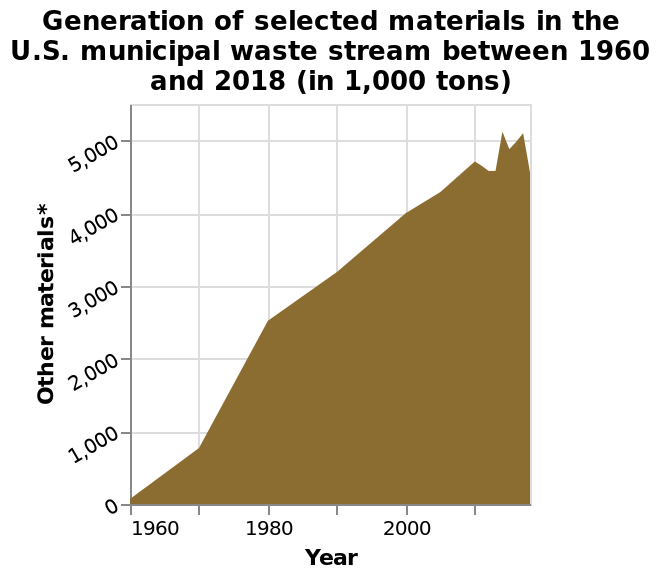<image>
What is the unit of measurement for the data in the area chart? The unit of measurement for the data is 1,000 tons. Was there a decrease in the generation of materials in 2010? Yes, in 2010 the generation of materials decreased for a short period. 